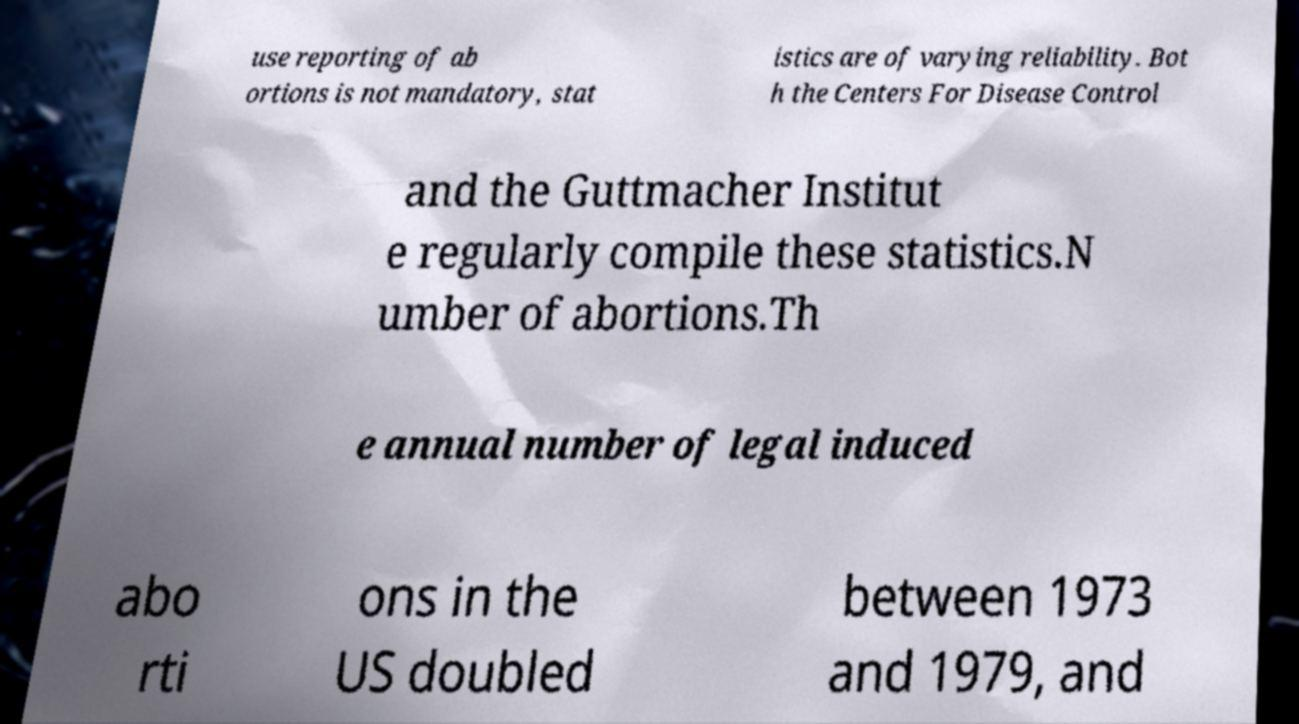Could you assist in decoding the text presented in this image and type it out clearly? use reporting of ab ortions is not mandatory, stat istics are of varying reliability. Bot h the Centers For Disease Control and the Guttmacher Institut e regularly compile these statistics.N umber of abortions.Th e annual number of legal induced abo rti ons in the US doubled between 1973 and 1979, and 